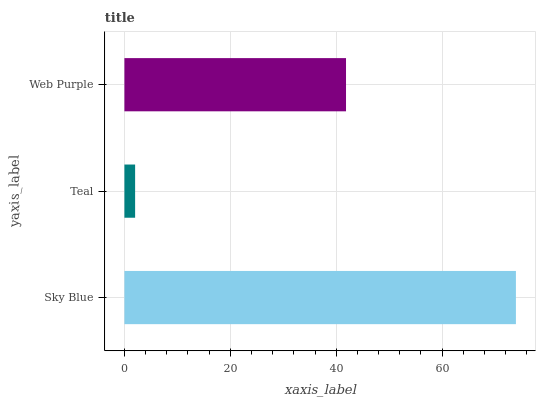Is Teal the minimum?
Answer yes or no. Yes. Is Sky Blue the maximum?
Answer yes or no. Yes. Is Web Purple the minimum?
Answer yes or no. No. Is Web Purple the maximum?
Answer yes or no. No. Is Web Purple greater than Teal?
Answer yes or no. Yes. Is Teal less than Web Purple?
Answer yes or no. Yes. Is Teal greater than Web Purple?
Answer yes or no. No. Is Web Purple less than Teal?
Answer yes or no. No. Is Web Purple the high median?
Answer yes or no. Yes. Is Web Purple the low median?
Answer yes or no. Yes. Is Sky Blue the high median?
Answer yes or no. No. Is Teal the low median?
Answer yes or no. No. 